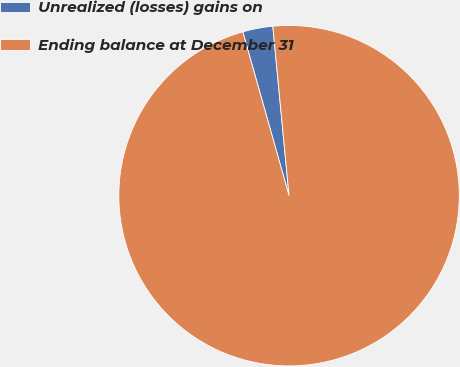<chart> <loc_0><loc_0><loc_500><loc_500><pie_chart><fcel>Unrealized (losses) gains on<fcel>Ending balance at December 31<nl><fcel>2.86%<fcel>97.14%<nl></chart> 